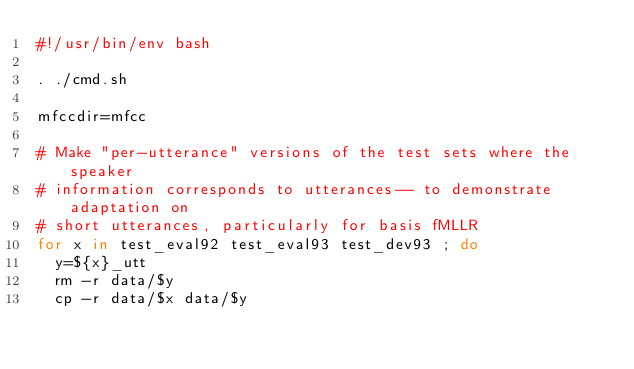<code> <loc_0><loc_0><loc_500><loc_500><_Bash_>#!/usr/bin/env bash

. ./cmd.sh

mfccdir=mfcc

# Make "per-utterance" versions of the test sets where the speaker
# information corresponds to utterances-- to demonstrate adaptation on
# short utterances, particularly for basis fMLLR
for x in test_eval92 test_eval93 test_dev93 ; do
  y=${x}_utt
  rm -r data/$y
  cp -r data/$x data/$y</code> 